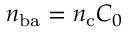<formula> <loc_0><loc_0><loc_500><loc_500>n _ { b a } = n _ { c } C _ { 0 }</formula> 